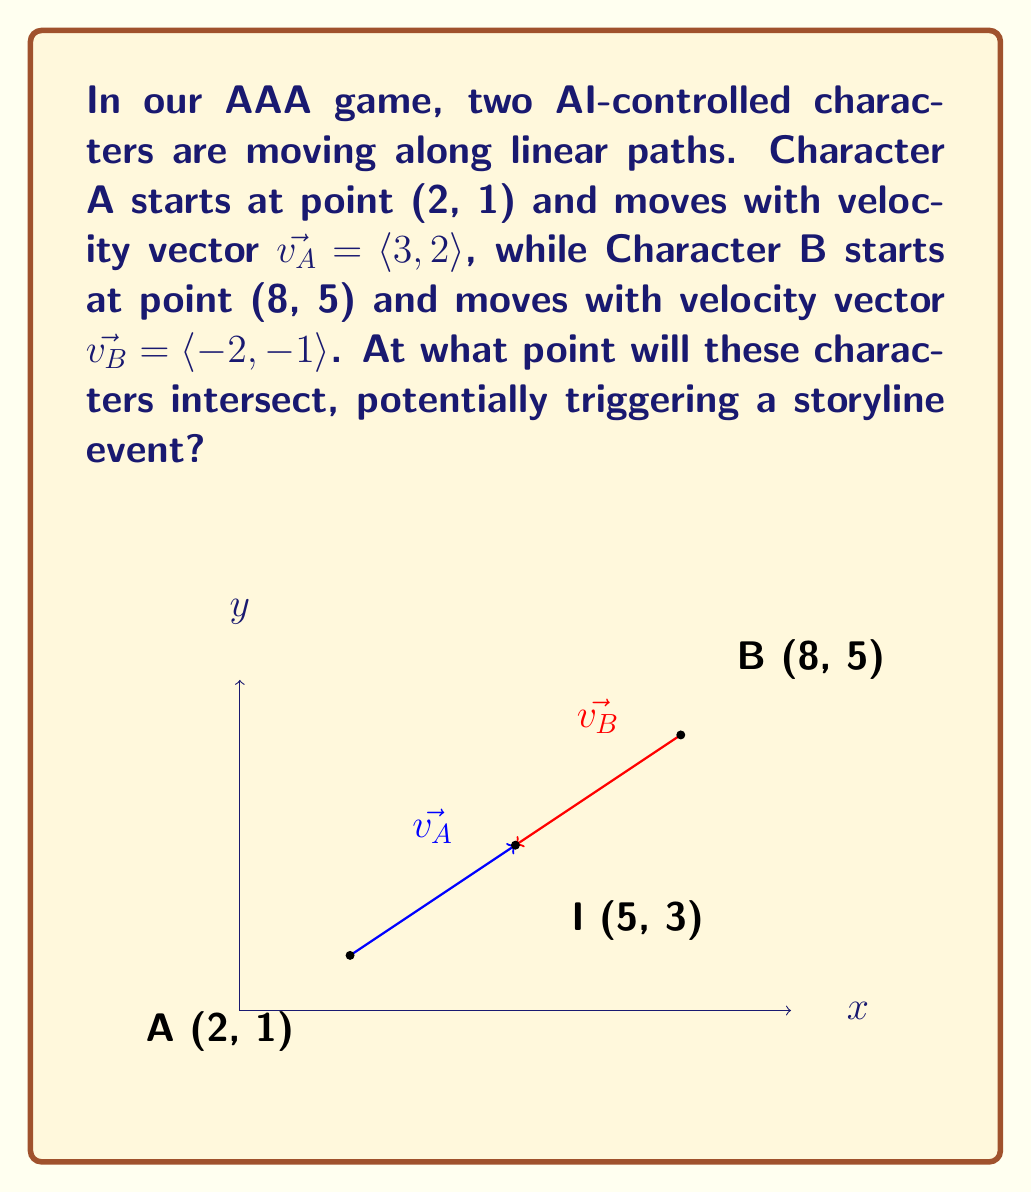Can you answer this question? To find the intersection point, we need to solve a system of parametric equations:

1) Character A's path: $x_A = 2 + 3t, y_A = 1 + 2t$
2) Character B's path: $x_B = 8 - 2s, y_B = 5 - s$

At the intersection point, $x_A = x_B$ and $y_A = y_B$. So:

3) $2 + 3t = 8 - 2s$
4) $1 + 2t = 5 - s$

Solving equation 4 for $s$:
5) $s = 4 - 2t$

Substituting this into equation 3:
6) $2 + 3t = 8 - 2(4 - 2t)$
7) $2 + 3t = 8 - 8 + 4t$
8) $2 + 3t = t$
9) $2 = -2t$
10) $t = -1$

Now we can find the intersection point by substituting $t = -1$ into Character A's path equations:

11) $x = 2 + 3(-1) = 2 - 3 = -1$
12) $y = 1 + 2(-1) = 1 - 2 = -1$

Therefore, the characters will intersect at the point (5, 3).
Answer: (5, 3) 